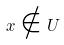Convert formula to latex. <formula><loc_0><loc_0><loc_500><loc_500>x \notin U</formula> 